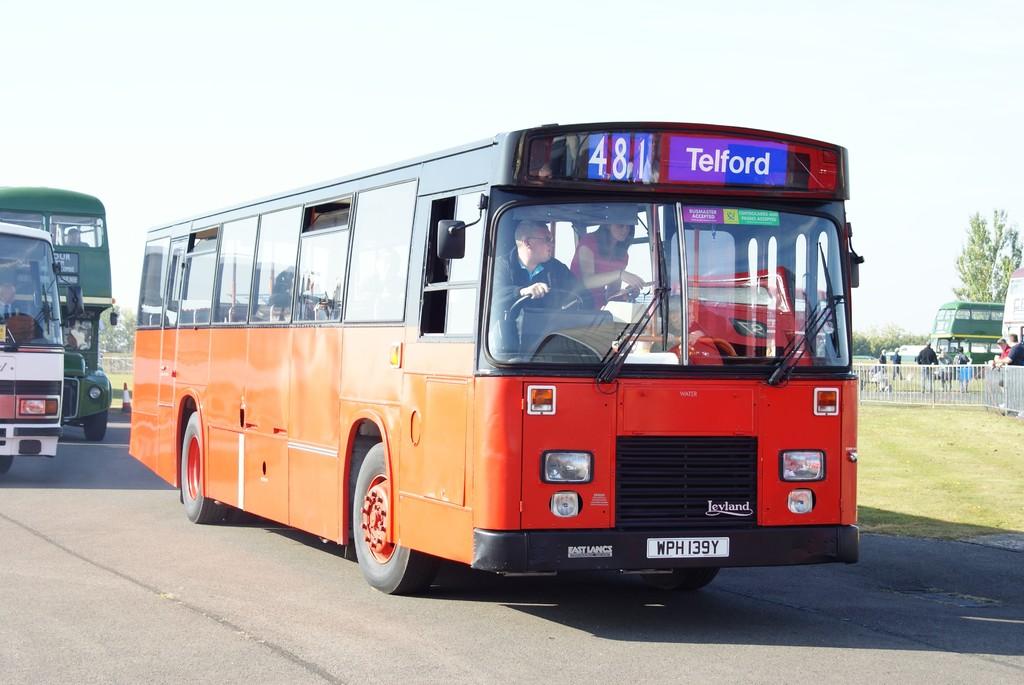What is the bus route number?
Make the answer very short. 481. Where is this bus going?
Provide a succinct answer. Telford. 